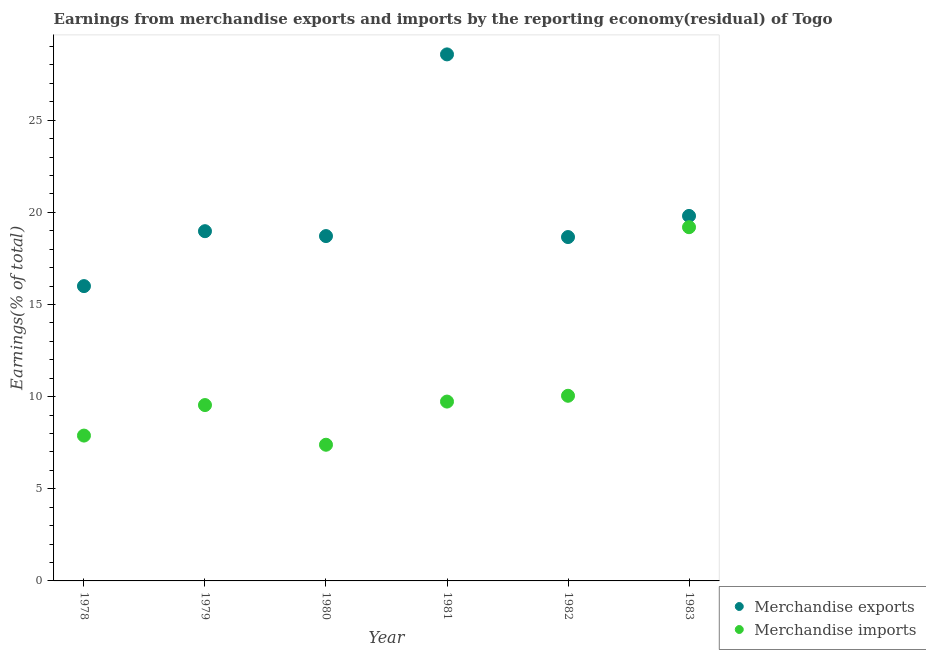How many different coloured dotlines are there?
Give a very brief answer. 2. Is the number of dotlines equal to the number of legend labels?
Provide a succinct answer. Yes. What is the earnings from merchandise imports in 1981?
Give a very brief answer. 9.73. Across all years, what is the maximum earnings from merchandise imports?
Offer a very short reply. 19.2. Across all years, what is the minimum earnings from merchandise exports?
Offer a terse response. 16. In which year was the earnings from merchandise exports maximum?
Ensure brevity in your answer.  1981. What is the total earnings from merchandise imports in the graph?
Ensure brevity in your answer.  63.8. What is the difference between the earnings from merchandise exports in 1978 and that in 1982?
Provide a short and direct response. -2.66. What is the difference between the earnings from merchandise exports in 1982 and the earnings from merchandise imports in 1979?
Make the answer very short. 9.12. What is the average earnings from merchandise exports per year?
Make the answer very short. 20.12. In the year 1981, what is the difference between the earnings from merchandise imports and earnings from merchandise exports?
Give a very brief answer. -18.84. In how many years, is the earnings from merchandise imports greater than 13 %?
Offer a very short reply. 1. What is the ratio of the earnings from merchandise imports in 1981 to that in 1983?
Offer a very short reply. 0.51. Is the earnings from merchandise imports in 1980 less than that in 1983?
Your answer should be compact. Yes. What is the difference between the highest and the second highest earnings from merchandise exports?
Offer a very short reply. 8.77. What is the difference between the highest and the lowest earnings from merchandise exports?
Keep it short and to the point. 12.57. Is the sum of the earnings from merchandise imports in 1978 and 1982 greater than the maximum earnings from merchandise exports across all years?
Ensure brevity in your answer.  No. Does the earnings from merchandise exports monotonically increase over the years?
Keep it short and to the point. No. Is the earnings from merchandise exports strictly greater than the earnings from merchandise imports over the years?
Give a very brief answer. Yes. Is the earnings from merchandise exports strictly less than the earnings from merchandise imports over the years?
Make the answer very short. No. What is the difference between two consecutive major ticks on the Y-axis?
Keep it short and to the point. 5. Are the values on the major ticks of Y-axis written in scientific E-notation?
Your answer should be compact. No. Does the graph contain any zero values?
Your response must be concise. No. What is the title of the graph?
Ensure brevity in your answer.  Earnings from merchandise exports and imports by the reporting economy(residual) of Togo. Does "Primary education" appear as one of the legend labels in the graph?
Your answer should be compact. No. What is the label or title of the X-axis?
Ensure brevity in your answer.  Year. What is the label or title of the Y-axis?
Your answer should be compact. Earnings(% of total). What is the Earnings(% of total) of Merchandise exports in 1978?
Offer a terse response. 16. What is the Earnings(% of total) of Merchandise imports in 1978?
Provide a succinct answer. 7.89. What is the Earnings(% of total) of Merchandise exports in 1979?
Provide a succinct answer. 18.98. What is the Earnings(% of total) of Merchandise imports in 1979?
Your response must be concise. 9.54. What is the Earnings(% of total) of Merchandise exports in 1980?
Provide a succinct answer. 18.71. What is the Earnings(% of total) of Merchandise imports in 1980?
Make the answer very short. 7.39. What is the Earnings(% of total) in Merchandise exports in 1981?
Ensure brevity in your answer.  28.57. What is the Earnings(% of total) in Merchandise imports in 1981?
Offer a very short reply. 9.73. What is the Earnings(% of total) of Merchandise exports in 1982?
Provide a short and direct response. 18.66. What is the Earnings(% of total) in Merchandise imports in 1982?
Ensure brevity in your answer.  10.05. What is the Earnings(% of total) in Merchandise exports in 1983?
Offer a very short reply. 19.81. What is the Earnings(% of total) of Merchandise imports in 1983?
Offer a very short reply. 19.2. Across all years, what is the maximum Earnings(% of total) of Merchandise exports?
Provide a succinct answer. 28.57. Across all years, what is the maximum Earnings(% of total) in Merchandise imports?
Your answer should be compact. 19.2. Across all years, what is the minimum Earnings(% of total) in Merchandise exports?
Give a very brief answer. 16. Across all years, what is the minimum Earnings(% of total) in Merchandise imports?
Your answer should be very brief. 7.39. What is the total Earnings(% of total) of Merchandise exports in the graph?
Offer a very short reply. 120.74. What is the total Earnings(% of total) of Merchandise imports in the graph?
Provide a short and direct response. 63.8. What is the difference between the Earnings(% of total) in Merchandise exports in 1978 and that in 1979?
Your response must be concise. -2.98. What is the difference between the Earnings(% of total) in Merchandise imports in 1978 and that in 1979?
Offer a terse response. -1.66. What is the difference between the Earnings(% of total) of Merchandise exports in 1978 and that in 1980?
Your answer should be very brief. -2.72. What is the difference between the Earnings(% of total) of Merchandise imports in 1978 and that in 1980?
Give a very brief answer. 0.5. What is the difference between the Earnings(% of total) of Merchandise exports in 1978 and that in 1981?
Ensure brevity in your answer.  -12.57. What is the difference between the Earnings(% of total) in Merchandise imports in 1978 and that in 1981?
Provide a succinct answer. -1.85. What is the difference between the Earnings(% of total) in Merchandise exports in 1978 and that in 1982?
Keep it short and to the point. -2.66. What is the difference between the Earnings(% of total) in Merchandise imports in 1978 and that in 1982?
Keep it short and to the point. -2.16. What is the difference between the Earnings(% of total) in Merchandise exports in 1978 and that in 1983?
Your answer should be compact. -3.81. What is the difference between the Earnings(% of total) in Merchandise imports in 1978 and that in 1983?
Provide a succinct answer. -11.31. What is the difference between the Earnings(% of total) of Merchandise exports in 1979 and that in 1980?
Make the answer very short. 0.27. What is the difference between the Earnings(% of total) of Merchandise imports in 1979 and that in 1980?
Keep it short and to the point. 2.15. What is the difference between the Earnings(% of total) of Merchandise exports in 1979 and that in 1981?
Your answer should be compact. -9.59. What is the difference between the Earnings(% of total) of Merchandise imports in 1979 and that in 1981?
Your answer should be compact. -0.19. What is the difference between the Earnings(% of total) of Merchandise exports in 1979 and that in 1982?
Your answer should be very brief. 0.32. What is the difference between the Earnings(% of total) in Merchandise imports in 1979 and that in 1982?
Offer a very short reply. -0.5. What is the difference between the Earnings(% of total) of Merchandise exports in 1979 and that in 1983?
Offer a terse response. -0.83. What is the difference between the Earnings(% of total) in Merchandise imports in 1979 and that in 1983?
Your answer should be very brief. -9.65. What is the difference between the Earnings(% of total) of Merchandise exports in 1980 and that in 1981?
Offer a terse response. -9.86. What is the difference between the Earnings(% of total) of Merchandise imports in 1980 and that in 1981?
Provide a succinct answer. -2.34. What is the difference between the Earnings(% of total) of Merchandise exports in 1980 and that in 1982?
Make the answer very short. 0.05. What is the difference between the Earnings(% of total) of Merchandise imports in 1980 and that in 1982?
Make the answer very short. -2.66. What is the difference between the Earnings(% of total) of Merchandise exports in 1980 and that in 1983?
Provide a short and direct response. -1.09. What is the difference between the Earnings(% of total) of Merchandise imports in 1980 and that in 1983?
Provide a succinct answer. -11.81. What is the difference between the Earnings(% of total) in Merchandise exports in 1981 and that in 1982?
Make the answer very short. 9.91. What is the difference between the Earnings(% of total) of Merchandise imports in 1981 and that in 1982?
Your answer should be compact. -0.31. What is the difference between the Earnings(% of total) in Merchandise exports in 1981 and that in 1983?
Offer a very short reply. 8.77. What is the difference between the Earnings(% of total) in Merchandise imports in 1981 and that in 1983?
Provide a short and direct response. -9.46. What is the difference between the Earnings(% of total) in Merchandise exports in 1982 and that in 1983?
Provide a short and direct response. -1.15. What is the difference between the Earnings(% of total) of Merchandise imports in 1982 and that in 1983?
Give a very brief answer. -9.15. What is the difference between the Earnings(% of total) of Merchandise exports in 1978 and the Earnings(% of total) of Merchandise imports in 1979?
Ensure brevity in your answer.  6.46. What is the difference between the Earnings(% of total) in Merchandise exports in 1978 and the Earnings(% of total) in Merchandise imports in 1980?
Offer a very short reply. 8.61. What is the difference between the Earnings(% of total) in Merchandise exports in 1978 and the Earnings(% of total) in Merchandise imports in 1981?
Your answer should be compact. 6.27. What is the difference between the Earnings(% of total) of Merchandise exports in 1978 and the Earnings(% of total) of Merchandise imports in 1982?
Your answer should be very brief. 5.95. What is the difference between the Earnings(% of total) of Merchandise exports in 1978 and the Earnings(% of total) of Merchandise imports in 1983?
Provide a succinct answer. -3.2. What is the difference between the Earnings(% of total) of Merchandise exports in 1979 and the Earnings(% of total) of Merchandise imports in 1980?
Your response must be concise. 11.59. What is the difference between the Earnings(% of total) of Merchandise exports in 1979 and the Earnings(% of total) of Merchandise imports in 1981?
Keep it short and to the point. 9.25. What is the difference between the Earnings(% of total) in Merchandise exports in 1979 and the Earnings(% of total) in Merchandise imports in 1982?
Your answer should be compact. 8.93. What is the difference between the Earnings(% of total) of Merchandise exports in 1979 and the Earnings(% of total) of Merchandise imports in 1983?
Provide a short and direct response. -0.22. What is the difference between the Earnings(% of total) in Merchandise exports in 1980 and the Earnings(% of total) in Merchandise imports in 1981?
Your answer should be very brief. 8.98. What is the difference between the Earnings(% of total) of Merchandise exports in 1980 and the Earnings(% of total) of Merchandise imports in 1982?
Keep it short and to the point. 8.67. What is the difference between the Earnings(% of total) in Merchandise exports in 1980 and the Earnings(% of total) in Merchandise imports in 1983?
Keep it short and to the point. -0.48. What is the difference between the Earnings(% of total) in Merchandise exports in 1981 and the Earnings(% of total) in Merchandise imports in 1982?
Your answer should be very brief. 18.53. What is the difference between the Earnings(% of total) of Merchandise exports in 1981 and the Earnings(% of total) of Merchandise imports in 1983?
Keep it short and to the point. 9.38. What is the difference between the Earnings(% of total) of Merchandise exports in 1982 and the Earnings(% of total) of Merchandise imports in 1983?
Your response must be concise. -0.54. What is the average Earnings(% of total) of Merchandise exports per year?
Keep it short and to the point. 20.12. What is the average Earnings(% of total) of Merchandise imports per year?
Your answer should be compact. 10.63. In the year 1978, what is the difference between the Earnings(% of total) of Merchandise exports and Earnings(% of total) of Merchandise imports?
Your response must be concise. 8.11. In the year 1979, what is the difference between the Earnings(% of total) in Merchandise exports and Earnings(% of total) in Merchandise imports?
Your answer should be compact. 9.44. In the year 1980, what is the difference between the Earnings(% of total) in Merchandise exports and Earnings(% of total) in Merchandise imports?
Your response must be concise. 11.32. In the year 1981, what is the difference between the Earnings(% of total) in Merchandise exports and Earnings(% of total) in Merchandise imports?
Provide a succinct answer. 18.84. In the year 1982, what is the difference between the Earnings(% of total) of Merchandise exports and Earnings(% of total) of Merchandise imports?
Keep it short and to the point. 8.61. In the year 1983, what is the difference between the Earnings(% of total) in Merchandise exports and Earnings(% of total) in Merchandise imports?
Your answer should be compact. 0.61. What is the ratio of the Earnings(% of total) of Merchandise exports in 1978 to that in 1979?
Offer a very short reply. 0.84. What is the ratio of the Earnings(% of total) in Merchandise imports in 1978 to that in 1979?
Your answer should be very brief. 0.83. What is the ratio of the Earnings(% of total) of Merchandise exports in 1978 to that in 1980?
Keep it short and to the point. 0.85. What is the ratio of the Earnings(% of total) in Merchandise imports in 1978 to that in 1980?
Ensure brevity in your answer.  1.07. What is the ratio of the Earnings(% of total) of Merchandise exports in 1978 to that in 1981?
Provide a short and direct response. 0.56. What is the ratio of the Earnings(% of total) in Merchandise imports in 1978 to that in 1981?
Provide a succinct answer. 0.81. What is the ratio of the Earnings(% of total) in Merchandise exports in 1978 to that in 1982?
Provide a succinct answer. 0.86. What is the ratio of the Earnings(% of total) of Merchandise imports in 1978 to that in 1982?
Provide a succinct answer. 0.79. What is the ratio of the Earnings(% of total) of Merchandise exports in 1978 to that in 1983?
Make the answer very short. 0.81. What is the ratio of the Earnings(% of total) of Merchandise imports in 1978 to that in 1983?
Your answer should be compact. 0.41. What is the ratio of the Earnings(% of total) in Merchandise exports in 1979 to that in 1980?
Provide a succinct answer. 1.01. What is the ratio of the Earnings(% of total) in Merchandise imports in 1979 to that in 1980?
Offer a very short reply. 1.29. What is the ratio of the Earnings(% of total) of Merchandise exports in 1979 to that in 1981?
Keep it short and to the point. 0.66. What is the ratio of the Earnings(% of total) in Merchandise imports in 1979 to that in 1981?
Your answer should be compact. 0.98. What is the ratio of the Earnings(% of total) of Merchandise exports in 1979 to that in 1982?
Make the answer very short. 1.02. What is the ratio of the Earnings(% of total) in Merchandise imports in 1979 to that in 1982?
Offer a terse response. 0.95. What is the ratio of the Earnings(% of total) of Merchandise exports in 1979 to that in 1983?
Offer a very short reply. 0.96. What is the ratio of the Earnings(% of total) in Merchandise imports in 1979 to that in 1983?
Your answer should be very brief. 0.5. What is the ratio of the Earnings(% of total) of Merchandise exports in 1980 to that in 1981?
Provide a succinct answer. 0.65. What is the ratio of the Earnings(% of total) in Merchandise imports in 1980 to that in 1981?
Ensure brevity in your answer.  0.76. What is the ratio of the Earnings(% of total) in Merchandise exports in 1980 to that in 1982?
Offer a very short reply. 1. What is the ratio of the Earnings(% of total) in Merchandise imports in 1980 to that in 1982?
Keep it short and to the point. 0.74. What is the ratio of the Earnings(% of total) of Merchandise exports in 1980 to that in 1983?
Your answer should be compact. 0.94. What is the ratio of the Earnings(% of total) in Merchandise imports in 1980 to that in 1983?
Offer a very short reply. 0.39. What is the ratio of the Earnings(% of total) in Merchandise exports in 1981 to that in 1982?
Your answer should be compact. 1.53. What is the ratio of the Earnings(% of total) of Merchandise imports in 1981 to that in 1982?
Offer a very short reply. 0.97. What is the ratio of the Earnings(% of total) of Merchandise exports in 1981 to that in 1983?
Your answer should be compact. 1.44. What is the ratio of the Earnings(% of total) in Merchandise imports in 1981 to that in 1983?
Provide a short and direct response. 0.51. What is the ratio of the Earnings(% of total) in Merchandise exports in 1982 to that in 1983?
Your answer should be compact. 0.94. What is the ratio of the Earnings(% of total) of Merchandise imports in 1982 to that in 1983?
Your answer should be very brief. 0.52. What is the difference between the highest and the second highest Earnings(% of total) of Merchandise exports?
Offer a very short reply. 8.77. What is the difference between the highest and the second highest Earnings(% of total) in Merchandise imports?
Give a very brief answer. 9.15. What is the difference between the highest and the lowest Earnings(% of total) in Merchandise exports?
Your answer should be compact. 12.57. What is the difference between the highest and the lowest Earnings(% of total) of Merchandise imports?
Offer a very short reply. 11.81. 